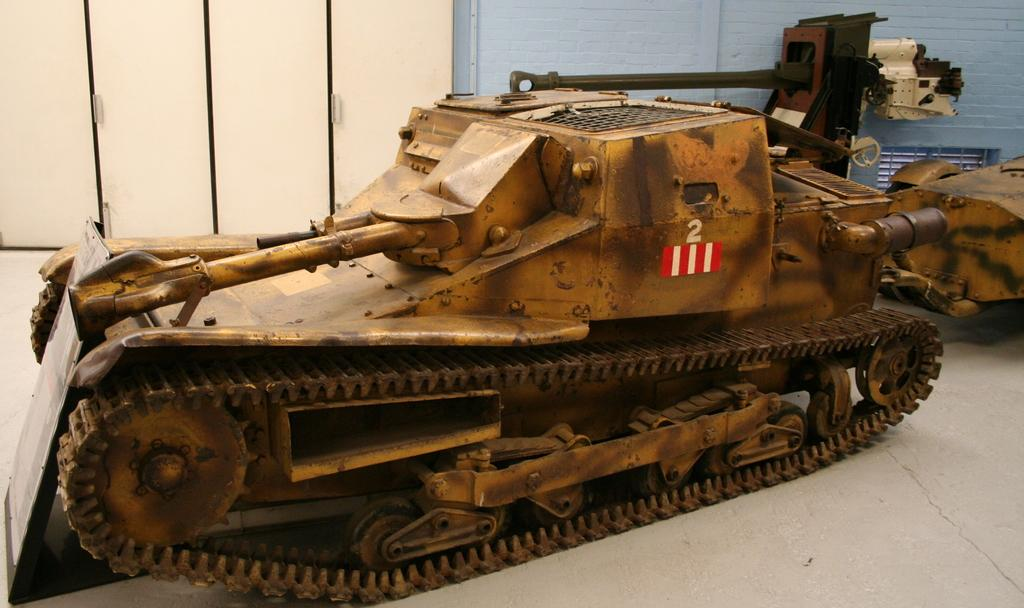What objects are on the floor in the image? There are vehicles on the floor in the image. What can be seen in the background of the image? There are doors and a wall visible in the background of the image. What type of rhythm can be heard coming from the vehicles in the image? There is no sound or rhythm associated with the vehicles in the image; they are stationary objects. 